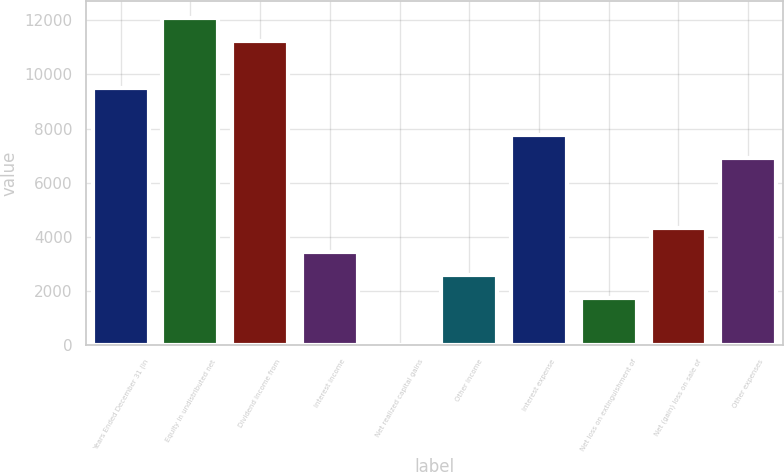Convert chart. <chart><loc_0><loc_0><loc_500><loc_500><bar_chart><fcel>Years Ended December 31 (in<fcel>Equity in undistributed net<fcel>Dividend income from<fcel>Interest income<fcel>Net realized capital gains<fcel>Other income<fcel>Interest expense<fcel>Net loss on extinguishment of<fcel>Net (gain) loss on sale of<fcel>Other expenses<nl><fcel>9496.1<fcel>12085.4<fcel>11222.3<fcel>3454.4<fcel>2<fcel>2591.3<fcel>7769.9<fcel>1728.2<fcel>4317.5<fcel>6906.8<nl></chart> 